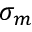Convert formula to latex. <formula><loc_0><loc_0><loc_500><loc_500>\sigma _ { m }</formula> 